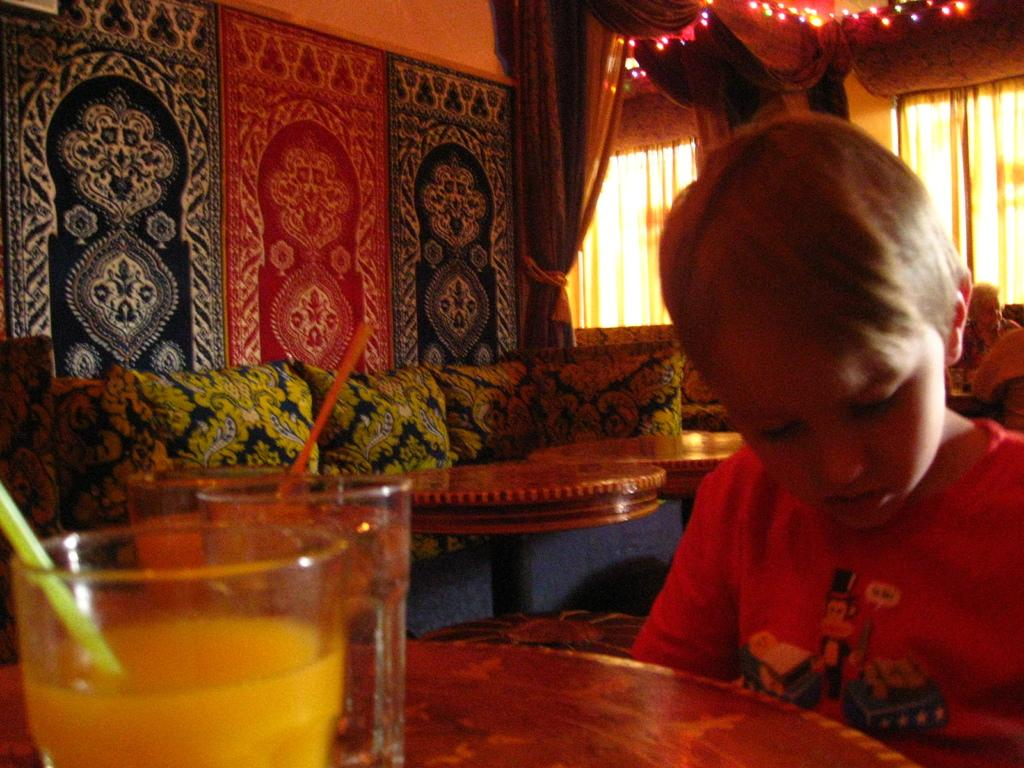Who is present in the image? There is a boy in the image. What is the boy doing in the image? The boy is sitting around a table. What can be seen on the table in the image? There is a glass on the table. What can be seen in the background of the image? There is a sheer, a curtain associated with the window, a window, a wall, a couch, a table, and pillows in the background of the image. What type of breakfast is the boy eating in the image? There is no indication of breakfast in the image, as no food is visible. Can you see the ocean in the background of the image? No, the image does not show the ocean; it features a window, a wall, a couch, a table, and pillows in the background. 